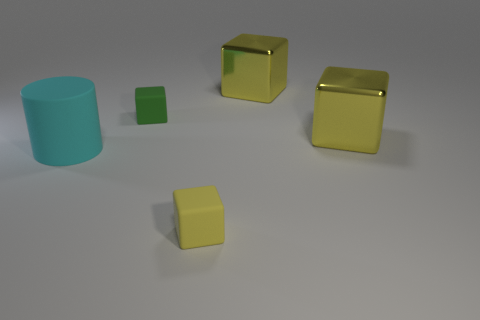There is a tiny yellow object that is the same shape as the green object; what material is it?
Offer a very short reply. Rubber. The big matte cylinder has what color?
Your answer should be very brief. Cyan. What number of things are either yellow cubes or big shiny cubes?
Give a very brief answer. 3. What is the shape of the large yellow shiny thing that is to the right of the large yellow object that is behind the green matte cube?
Provide a succinct answer. Cube. How many other things are there of the same material as the cyan thing?
Give a very brief answer. 2. Do the tiny yellow block and the cube that is on the left side of the tiny yellow cube have the same material?
Ensure brevity in your answer.  Yes. What number of things are either small matte blocks in front of the green matte cube or large metal cubes that are behind the big cyan cylinder?
Give a very brief answer. 3. What number of other objects are the same color as the big matte thing?
Provide a short and direct response. 0. Are there more big yellow cubes that are in front of the large cyan matte object than tiny matte things that are behind the small green block?
Your answer should be compact. No. What number of cubes are either big rubber objects or large yellow metallic things?
Provide a succinct answer. 2. 